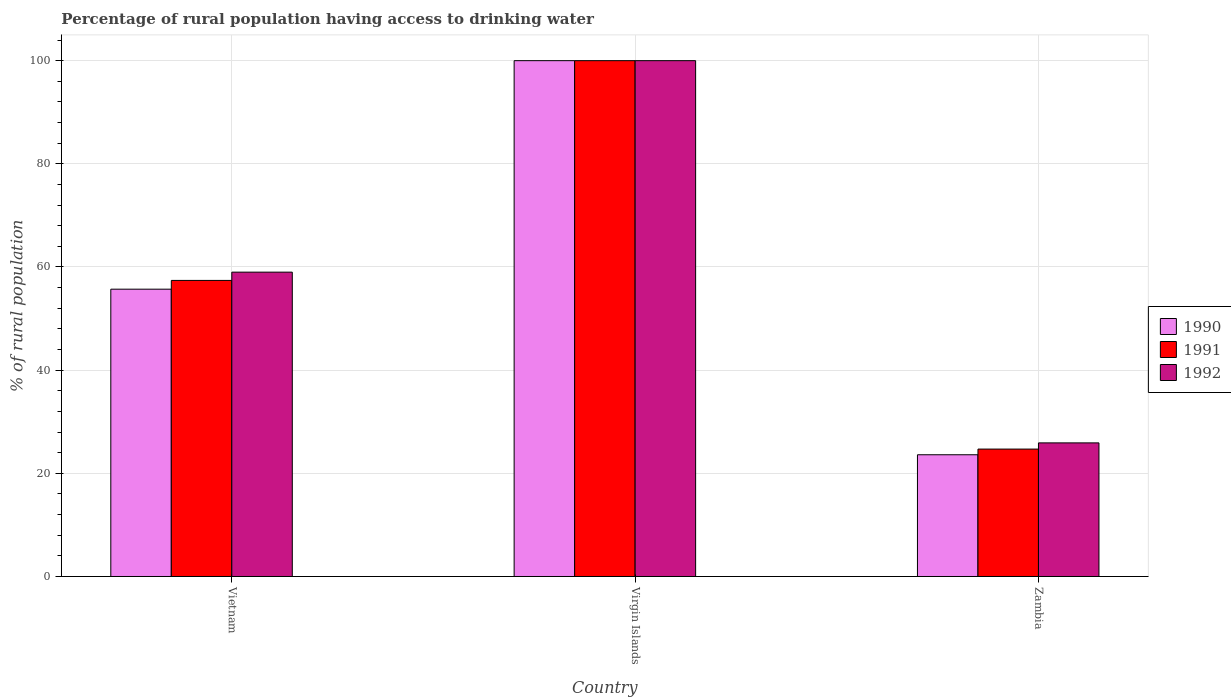How many different coloured bars are there?
Provide a short and direct response. 3. How many groups of bars are there?
Your answer should be very brief. 3. Are the number of bars per tick equal to the number of legend labels?
Your response must be concise. Yes. How many bars are there on the 3rd tick from the left?
Provide a succinct answer. 3. How many bars are there on the 2nd tick from the right?
Give a very brief answer. 3. What is the label of the 1st group of bars from the left?
Your answer should be compact. Vietnam. Across all countries, what is the minimum percentage of rural population having access to drinking water in 1990?
Your answer should be compact. 23.6. In which country was the percentage of rural population having access to drinking water in 1992 maximum?
Your response must be concise. Virgin Islands. In which country was the percentage of rural population having access to drinking water in 1991 minimum?
Keep it short and to the point. Zambia. What is the total percentage of rural population having access to drinking water in 1992 in the graph?
Make the answer very short. 184.9. What is the difference between the percentage of rural population having access to drinking water in 1992 in Virgin Islands and that in Zambia?
Your answer should be very brief. 74.1. What is the average percentage of rural population having access to drinking water in 1990 per country?
Provide a short and direct response. 59.77. What is the difference between the percentage of rural population having access to drinking water of/in 1991 and percentage of rural population having access to drinking water of/in 1990 in Zambia?
Ensure brevity in your answer.  1.1. What is the ratio of the percentage of rural population having access to drinking water in 1990 in Virgin Islands to that in Zambia?
Your answer should be very brief. 4.24. Is the percentage of rural population having access to drinking water in 1992 in Vietnam less than that in Zambia?
Offer a terse response. No. Is the difference between the percentage of rural population having access to drinking water in 1991 in Virgin Islands and Zambia greater than the difference between the percentage of rural population having access to drinking water in 1990 in Virgin Islands and Zambia?
Offer a very short reply. No. What is the difference between the highest and the second highest percentage of rural population having access to drinking water in 1992?
Ensure brevity in your answer.  -33.1. What is the difference between the highest and the lowest percentage of rural population having access to drinking water in 1991?
Your answer should be very brief. 75.3. Is the sum of the percentage of rural population having access to drinking water in 1991 in Vietnam and Zambia greater than the maximum percentage of rural population having access to drinking water in 1990 across all countries?
Offer a very short reply. No. What does the 2nd bar from the right in Virgin Islands represents?
Make the answer very short. 1991. How many bars are there?
Ensure brevity in your answer.  9. How many countries are there in the graph?
Ensure brevity in your answer.  3. Are the values on the major ticks of Y-axis written in scientific E-notation?
Ensure brevity in your answer.  No. Does the graph contain any zero values?
Your answer should be very brief. No. Does the graph contain grids?
Your response must be concise. Yes. How are the legend labels stacked?
Provide a succinct answer. Vertical. What is the title of the graph?
Offer a terse response. Percentage of rural population having access to drinking water. What is the label or title of the X-axis?
Your response must be concise. Country. What is the label or title of the Y-axis?
Your answer should be very brief. % of rural population. What is the % of rural population of 1990 in Vietnam?
Ensure brevity in your answer.  55.7. What is the % of rural population of 1991 in Vietnam?
Your answer should be compact. 57.4. What is the % of rural population in 1990 in Virgin Islands?
Give a very brief answer. 100. What is the % of rural population in 1990 in Zambia?
Make the answer very short. 23.6. What is the % of rural population in 1991 in Zambia?
Offer a terse response. 24.7. What is the % of rural population of 1992 in Zambia?
Offer a very short reply. 25.9. Across all countries, what is the maximum % of rural population in 1992?
Ensure brevity in your answer.  100. Across all countries, what is the minimum % of rural population in 1990?
Your answer should be very brief. 23.6. Across all countries, what is the minimum % of rural population of 1991?
Offer a very short reply. 24.7. Across all countries, what is the minimum % of rural population in 1992?
Offer a very short reply. 25.9. What is the total % of rural population in 1990 in the graph?
Ensure brevity in your answer.  179.3. What is the total % of rural population of 1991 in the graph?
Your answer should be very brief. 182.1. What is the total % of rural population in 1992 in the graph?
Your response must be concise. 184.9. What is the difference between the % of rural population of 1990 in Vietnam and that in Virgin Islands?
Your response must be concise. -44.3. What is the difference between the % of rural population of 1991 in Vietnam and that in Virgin Islands?
Offer a very short reply. -42.6. What is the difference between the % of rural population of 1992 in Vietnam and that in Virgin Islands?
Offer a very short reply. -41. What is the difference between the % of rural population in 1990 in Vietnam and that in Zambia?
Keep it short and to the point. 32.1. What is the difference between the % of rural population in 1991 in Vietnam and that in Zambia?
Your response must be concise. 32.7. What is the difference between the % of rural population in 1992 in Vietnam and that in Zambia?
Your answer should be very brief. 33.1. What is the difference between the % of rural population in 1990 in Virgin Islands and that in Zambia?
Your answer should be compact. 76.4. What is the difference between the % of rural population in 1991 in Virgin Islands and that in Zambia?
Your answer should be very brief. 75.3. What is the difference between the % of rural population of 1992 in Virgin Islands and that in Zambia?
Your answer should be very brief. 74.1. What is the difference between the % of rural population of 1990 in Vietnam and the % of rural population of 1991 in Virgin Islands?
Provide a short and direct response. -44.3. What is the difference between the % of rural population of 1990 in Vietnam and the % of rural population of 1992 in Virgin Islands?
Provide a succinct answer. -44.3. What is the difference between the % of rural population in 1991 in Vietnam and the % of rural population in 1992 in Virgin Islands?
Offer a very short reply. -42.6. What is the difference between the % of rural population of 1990 in Vietnam and the % of rural population of 1992 in Zambia?
Offer a terse response. 29.8. What is the difference between the % of rural population of 1991 in Vietnam and the % of rural population of 1992 in Zambia?
Make the answer very short. 31.5. What is the difference between the % of rural population in 1990 in Virgin Islands and the % of rural population in 1991 in Zambia?
Provide a succinct answer. 75.3. What is the difference between the % of rural population in 1990 in Virgin Islands and the % of rural population in 1992 in Zambia?
Your answer should be compact. 74.1. What is the difference between the % of rural population in 1991 in Virgin Islands and the % of rural population in 1992 in Zambia?
Keep it short and to the point. 74.1. What is the average % of rural population of 1990 per country?
Your answer should be compact. 59.77. What is the average % of rural population in 1991 per country?
Your response must be concise. 60.7. What is the average % of rural population of 1992 per country?
Provide a short and direct response. 61.63. What is the difference between the % of rural population in 1990 and % of rural population in 1991 in Vietnam?
Your response must be concise. -1.7. What is the difference between the % of rural population of 1990 and % of rural population of 1991 in Virgin Islands?
Your answer should be compact. 0. What is the difference between the % of rural population in 1990 and % of rural population in 1991 in Zambia?
Ensure brevity in your answer.  -1.1. What is the difference between the % of rural population of 1991 and % of rural population of 1992 in Zambia?
Make the answer very short. -1.2. What is the ratio of the % of rural population of 1990 in Vietnam to that in Virgin Islands?
Offer a very short reply. 0.56. What is the ratio of the % of rural population of 1991 in Vietnam to that in Virgin Islands?
Keep it short and to the point. 0.57. What is the ratio of the % of rural population of 1992 in Vietnam to that in Virgin Islands?
Make the answer very short. 0.59. What is the ratio of the % of rural population in 1990 in Vietnam to that in Zambia?
Provide a short and direct response. 2.36. What is the ratio of the % of rural population of 1991 in Vietnam to that in Zambia?
Your answer should be very brief. 2.32. What is the ratio of the % of rural population of 1992 in Vietnam to that in Zambia?
Offer a terse response. 2.28. What is the ratio of the % of rural population in 1990 in Virgin Islands to that in Zambia?
Provide a short and direct response. 4.24. What is the ratio of the % of rural population of 1991 in Virgin Islands to that in Zambia?
Provide a succinct answer. 4.05. What is the ratio of the % of rural population in 1992 in Virgin Islands to that in Zambia?
Provide a succinct answer. 3.86. What is the difference between the highest and the second highest % of rural population in 1990?
Your answer should be compact. 44.3. What is the difference between the highest and the second highest % of rural population in 1991?
Offer a very short reply. 42.6. What is the difference between the highest and the lowest % of rural population of 1990?
Offer a very short reply. 76.4. What is the difference between the highest and the lowest % of rural population of 1991?
Offer a terse response. 75.3. What is the difference between the highest and the lowest % of rural population in 1992?
Offer a terse response. 74.1. 